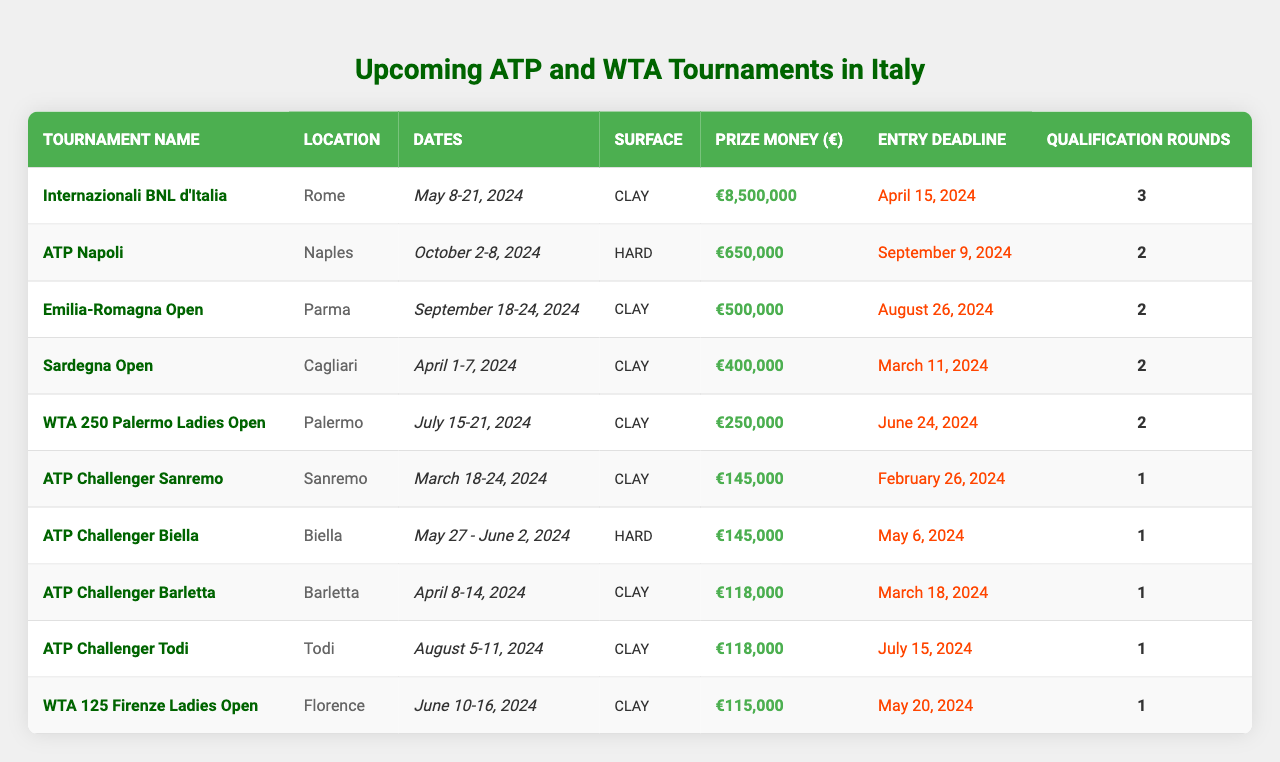What is the prize money for the Internazionali BNL d'Italia? The prize money for this tournament is listed in the table under the "Prize Money (€)" column. It shows €8,500,000.
Answer: €8,500,000 How many qualification rounds are there for the ATP Challenger Sanremo? The number of qualification rounds can be found in the "Qualification Rounds" column of the table for ATP Challenger Sanremo, which states there is 1 round.
Answer: 1 Which tournament in Italy has the highest prize money? By comparing the prize money of all tournaments listed in the table, it can be seen that the Internazionali BNL d'Italia has the highest prize money at €8,500,000.
Answer: Internazionali BNL d'Italia Are all the tournaments listed in the table played on clay surfaces? By examining the "Surface" column, not all tournaments are on clay; for instance, ATP Napoli and ATP Challenger Biella are held on hard surfaces.
Answer: No How much total prize money is offered for the ATP Challenger events? The prize money for all ATP Challenger events listed is calculated by adding €145,000 for Sanremo, €145,000 for Biella, €118,000 for Barletta, and €118,000 for Todi, resulting in a total of €526,000.
Answer: €526,000 What is the deadline for entering the WTA 250 Palermo Ladies Open? The entry deadline for this tournament is provided in the "Entry Deadline" column and is listed as June 24, 2024.
Answer: June 24, 2024 Which tournament has the latest start date in 2024? By looking at the "Dates" column, the latest date listed is for ATP Napoli, which starts on October 2, 2024.
Answer: ATP Napoli How many tournaments take place in April 2024? Counting the tournaments listed in the months of April, the table shows that there are two: the Sardegna Open (April 1-7) and ATP Challenger Barletta (April 8-14).
Answer: 2 Is there a WTA tournament taking place in October 2024? The table shows all listed tournaments, and the last tournament listed is in October, which is ATP Napoli, so there are no WTA tournaments scheduled for this month.
Answer: No What is the average number of qualification rounds across all tournaments? To find the average, first, sum the qualification rounds: (3 + 2 + 2 + 2 + 2 + 1 + 1 + 1 + 1 + 1) = 16 and divide by the number of tournaments (10), resulting in an average of 1.6 rounds.
Answer: 1.6 